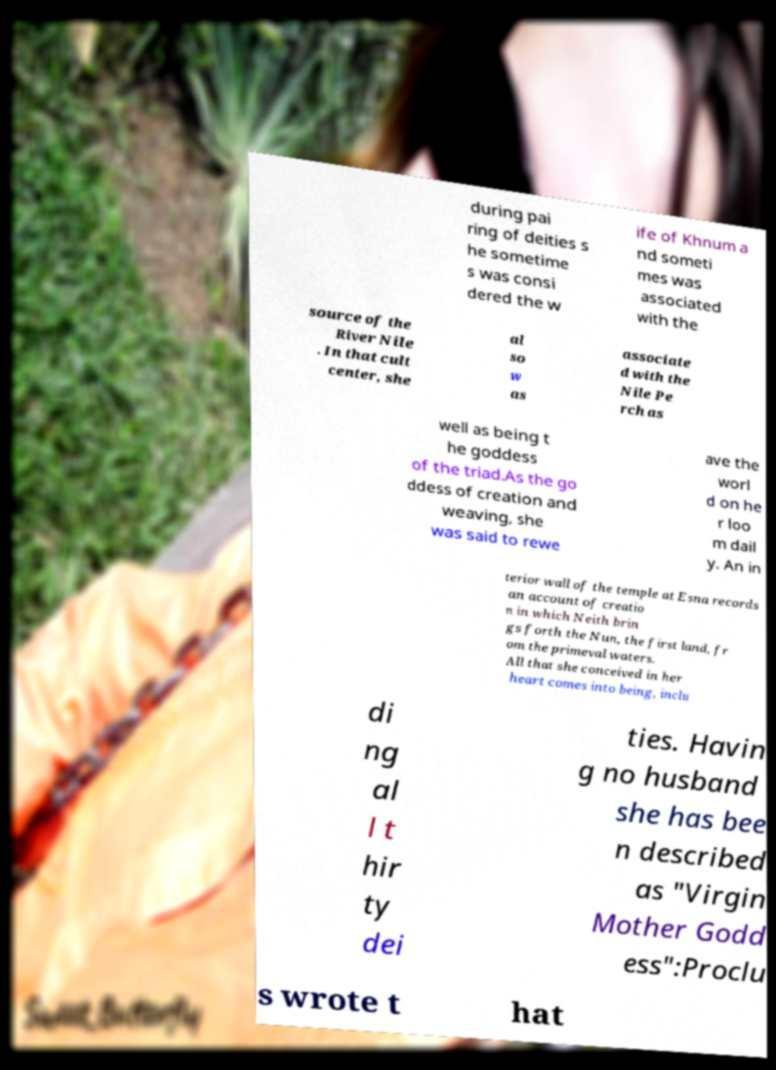What messages or text are displayed in this image? I need them in a readable, typed format. during pai ring of deities s he sometime s was consi dered the w ife of Khnum a nd someti mes was associated with the source of the River Nile . In that cult center, she al so w as associate d with the Nile Pe rch as well as being t he goddess of the triad.As the go ddess of creation and weaving, she was said to rewe ave the worl d on he r loo m dail y. An in terior wall of the temple at Esna records an account of creatio n in which Neith brin gs forth the Nun, the first land, fr om the primeval waters. All that she conceived in her heart comes into being, inclu di ng al l t hir ty dei ties. Havin g no husband she has bee n described as "Virgin Mother Godd ess":Proclu s wrote t hat 